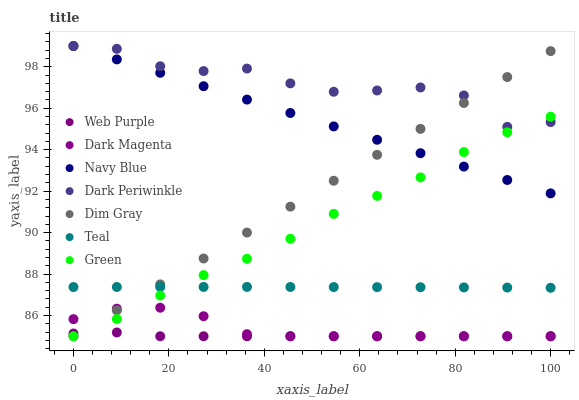Does Web Purple have the minimum area under the curve?
Answer yes or no. Yes. Does Dark Periwinkle have the maximum area under the curve?
Answer yes or no. Yes. Does Dark Magenta have the minimum area under the curve?
Answer yes or no. No. Does Dark Magenta have the maximum area under the curve?
Answer yes or no. No. Is Dim Gray the smoothest?
Answer yes or no. Yes. Is Dark Periwinkle the roughest?
Answer yes or no. Yes. Is Dark Magenta the smoothest?
Answer yes or no. No. Is Dark Magenta the roughest?
Answer yes or no. No. Does Dim Gray have the lowest value?
Answer yes or no. Yes. Does Navy Blue have the lowest value?
Answer yes or no. No. Does Dark Periwinkle have the highest value?
Answer yes or no. Yes. Does Dark Magenta have the highest value?
Answer yes or no. No. Is Web Purple less than Navy Blue?
Answer yes or no. Yes. Is Navy Blue greater than Web Purple?
Answer yes or no. Yes. Does Web Purple intersect Dark Magenta?
Answer yes or no. Yes. Is Web Purple less than Dark Magenta?
Answer yes or no. No. Is Web Purple greater than Dark Magenta?
Answer yes or no. No. Does Web Purple intersect Navy Blue?
Answer yes or no. No. 